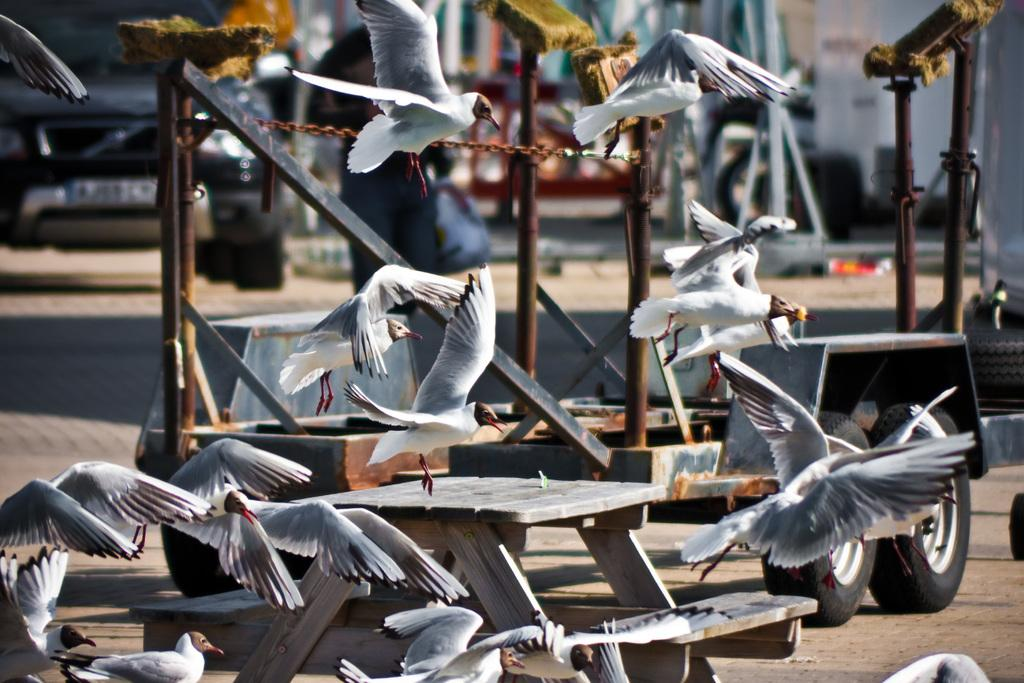What is happening in the sky in the image? There are birds flying in the image. What type of vehicle can be seen in the image? There is a vehicle with rust iron in the image. Where is the black car located in the image? The black car is on the left side of the image. Can you see any lizards crawling on the black car in the image? There are no lizards present in the image; it features birds flying and a vehicle with rust iron. What type of paper is being used to cover the rust iron on the vehicle? There is no paper mentioned or visible in the image; it only shows a vehicle with rust iron and a black car on the left side. 